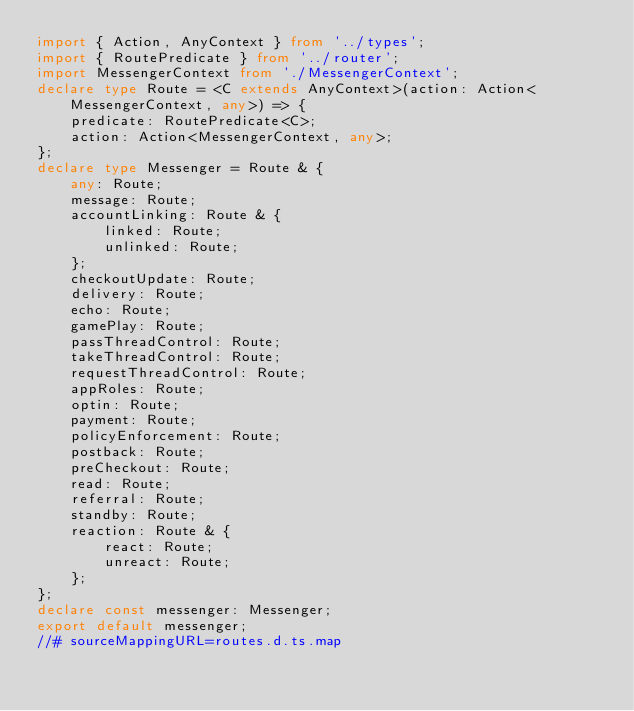Convert code to text. <code><loc_0><loc_0><loc_500><loc_500><_TypeScript_>import { Action, AnyContext } from '../types';
import { RoutePredicate } from '../router';
import MessengerContext from './MessengerContext';
declare type Route = <C extends AnyContext>(action: Action<MessengerContext, any>) => {
    predicate: RoutePredicate<C>;
    action: Action<MessengerContext, any>;
};
declare type Messenger = Route & {
    any: Route;
    message: Route;
    accountLinking: Route & {
        linked: Route;
        unlinked: Route;
    };
    checkoutUpdate: Route;
    delivery: Route;
    echo: Route;
    gamePlay: Route;
    passThreadControl: Route;
    takeThreadControl: Route;
    requestThreadControl: Route;
    appRoles: Route;
    optin: Route;
    payment: Route;
    policyEnforcement: Route;
    postback: Route;
    preCheckout: Route;
    read: Route;
    referral: Route;
    standby: Route;
    reaction: Route & {
        react: Route;
        unreact: Route;
    };
};
declare const messenger: Messenger;
export default messenger;
//# sourceMappingURL=routes.d.ts.map</code> 